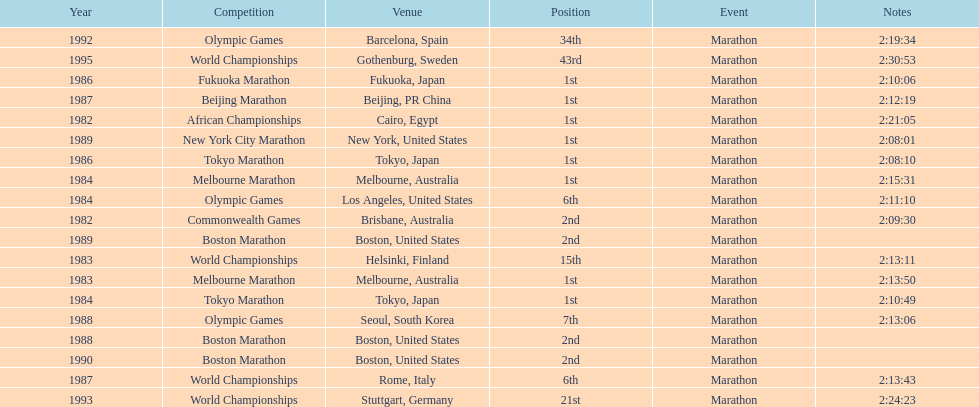What were the number of times the venue was located in the united states? 5. 